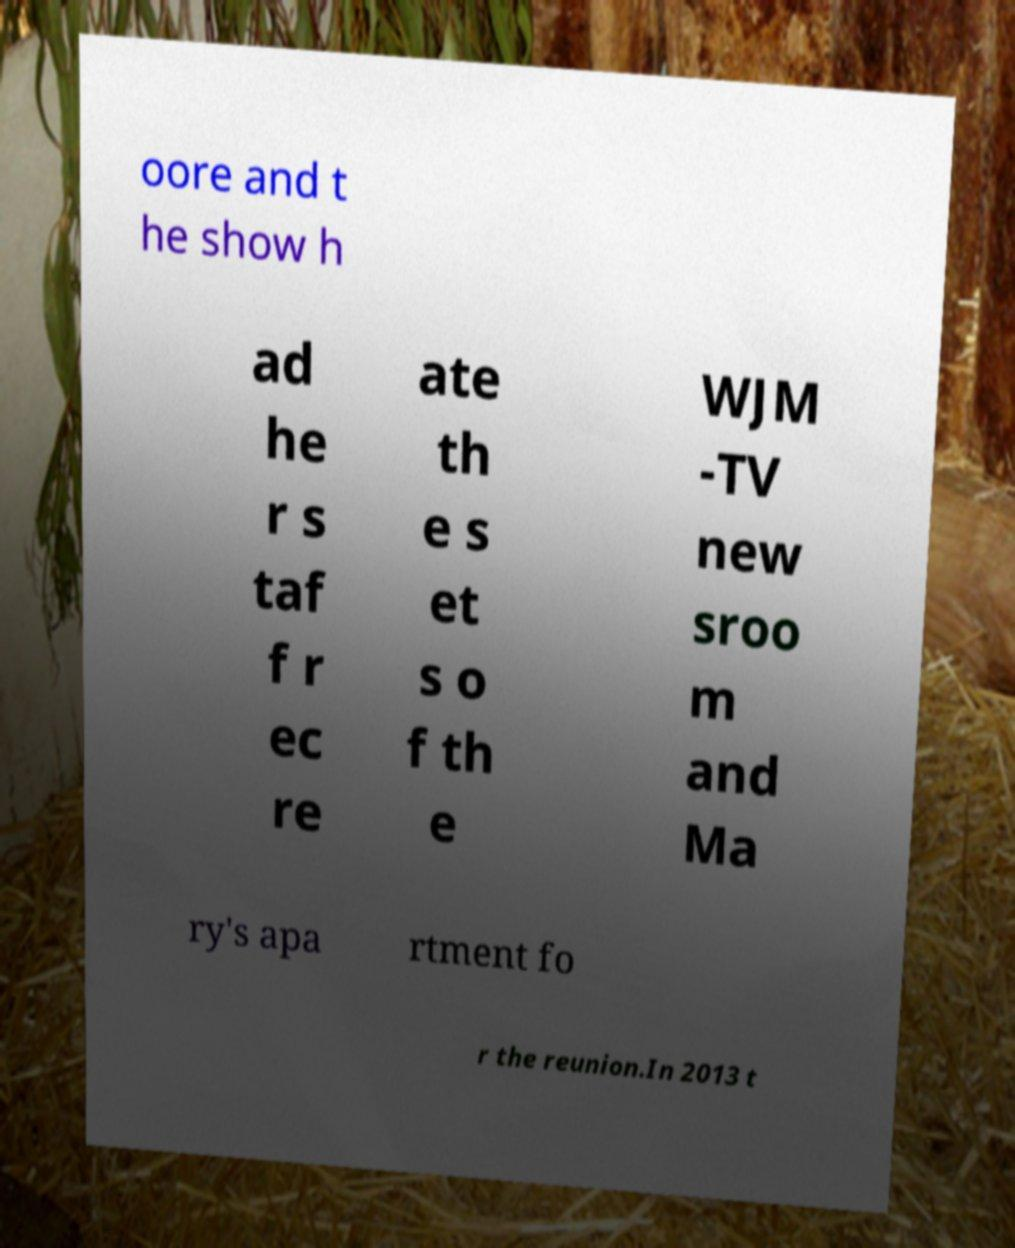There's text embedded in this image that I need extracted. Can you transcribe it verbatim? oore and t he show h ad he r s taf f r ec re ate th e s et s o f th e WJM -TV new sroo m and Ma ry's apa rtment fo r the reunion.In 2013 t 